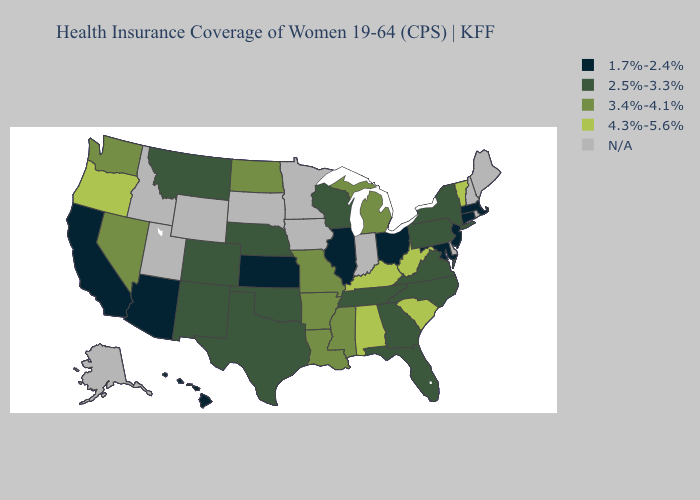What is the value of Michigan?
Give a very brief answer. 3.4%-4.1%. Does Kentucky have the lowest value in the USA?
Answer briefly. No. Among the states that border Oklahoma , does Arkansas have the lowest value?
Quick response, please. No. What is the lowest value in states that border North Carolina?
Keep it brief. 2.5%-3.3%. Does Oregon have the highest value in the West?
Be succinct. Yes. What is the lowest value in the West?
Answer briefly. 1.7%-2.4%. Which states have the highest value in the USA?
Answer briefly. Alabama, Kentucky, Oregon, South Carolina, Vermont, West Virginia. What is the value of Ohio?
Quick response, please. 1.7%-2.4%. What is the value of Maryland?
Keep it brief. 1.7%-2.4%. What is the lowest value in states that border Idaho?
Concise answer only. 2.5%-3.3%. What is the value of Kentucky?
Keep it brief. 4.3%-5.6%. Among the states that border North Dakota , which have the lowest value?
Be succinct. Montana. Name the states that have a value in the range 4.3%-5.6%?
Keep it brief. Alabama, Kentucky, Oregon, South Carolina, Vermont, West Virginia. What is the highest value in the USA?
Give a very brief answer. 4.3%-5.6%. Which states have the lowest value in the USA?
Quick response, please. Arizona, California, Connecticut, Hawaii, Illinois, Kansas, Maryland, Massachusetts, New Jersey, Ohio. 